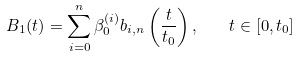Convert formula to latex. <formula><loc_0><loc_0><loc_500><loc_500>B _ { 1 } ( t ) = \sum _ { i = 0 } ^ { n } \beta _ { 0 } ^ { ( i ) } b _ { i , n } \left ( { \frac { t } { t _ { 0 } } } \right ) { , } \quad t \in [ 0 , t _ { 0 } ]</formula> 